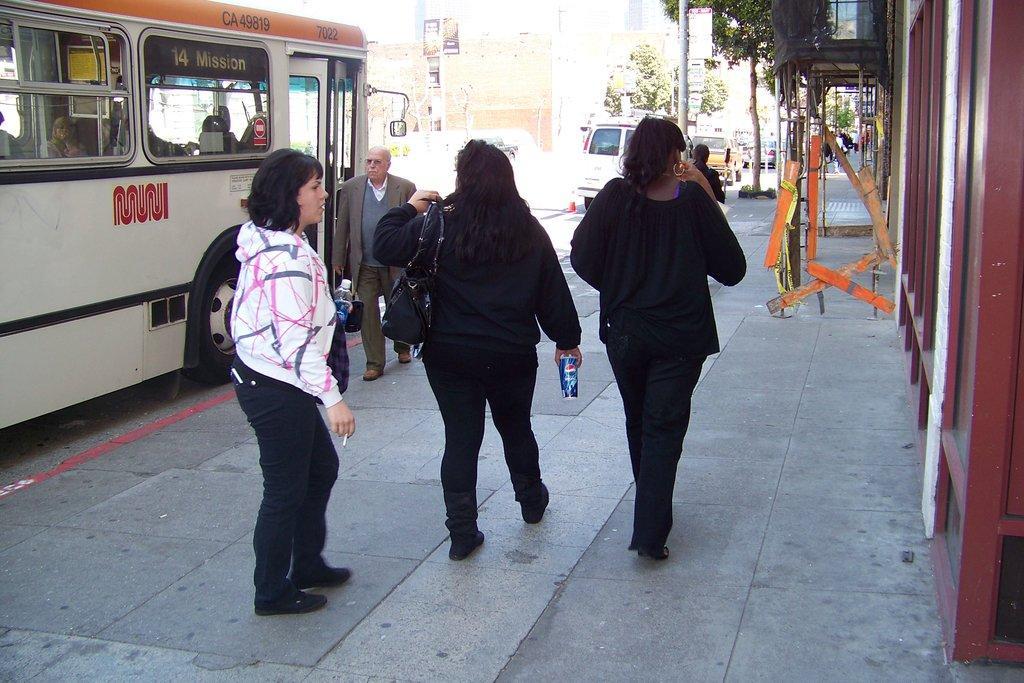Describe this image in one or two sentences. In the image we can see there are people standing on the footpath and there is a person holding juice can in her hand. There is a woman holding water bottle and cigarette in her hand. There are vehicles parked on the road and there are trees. Behind there are buildings. 